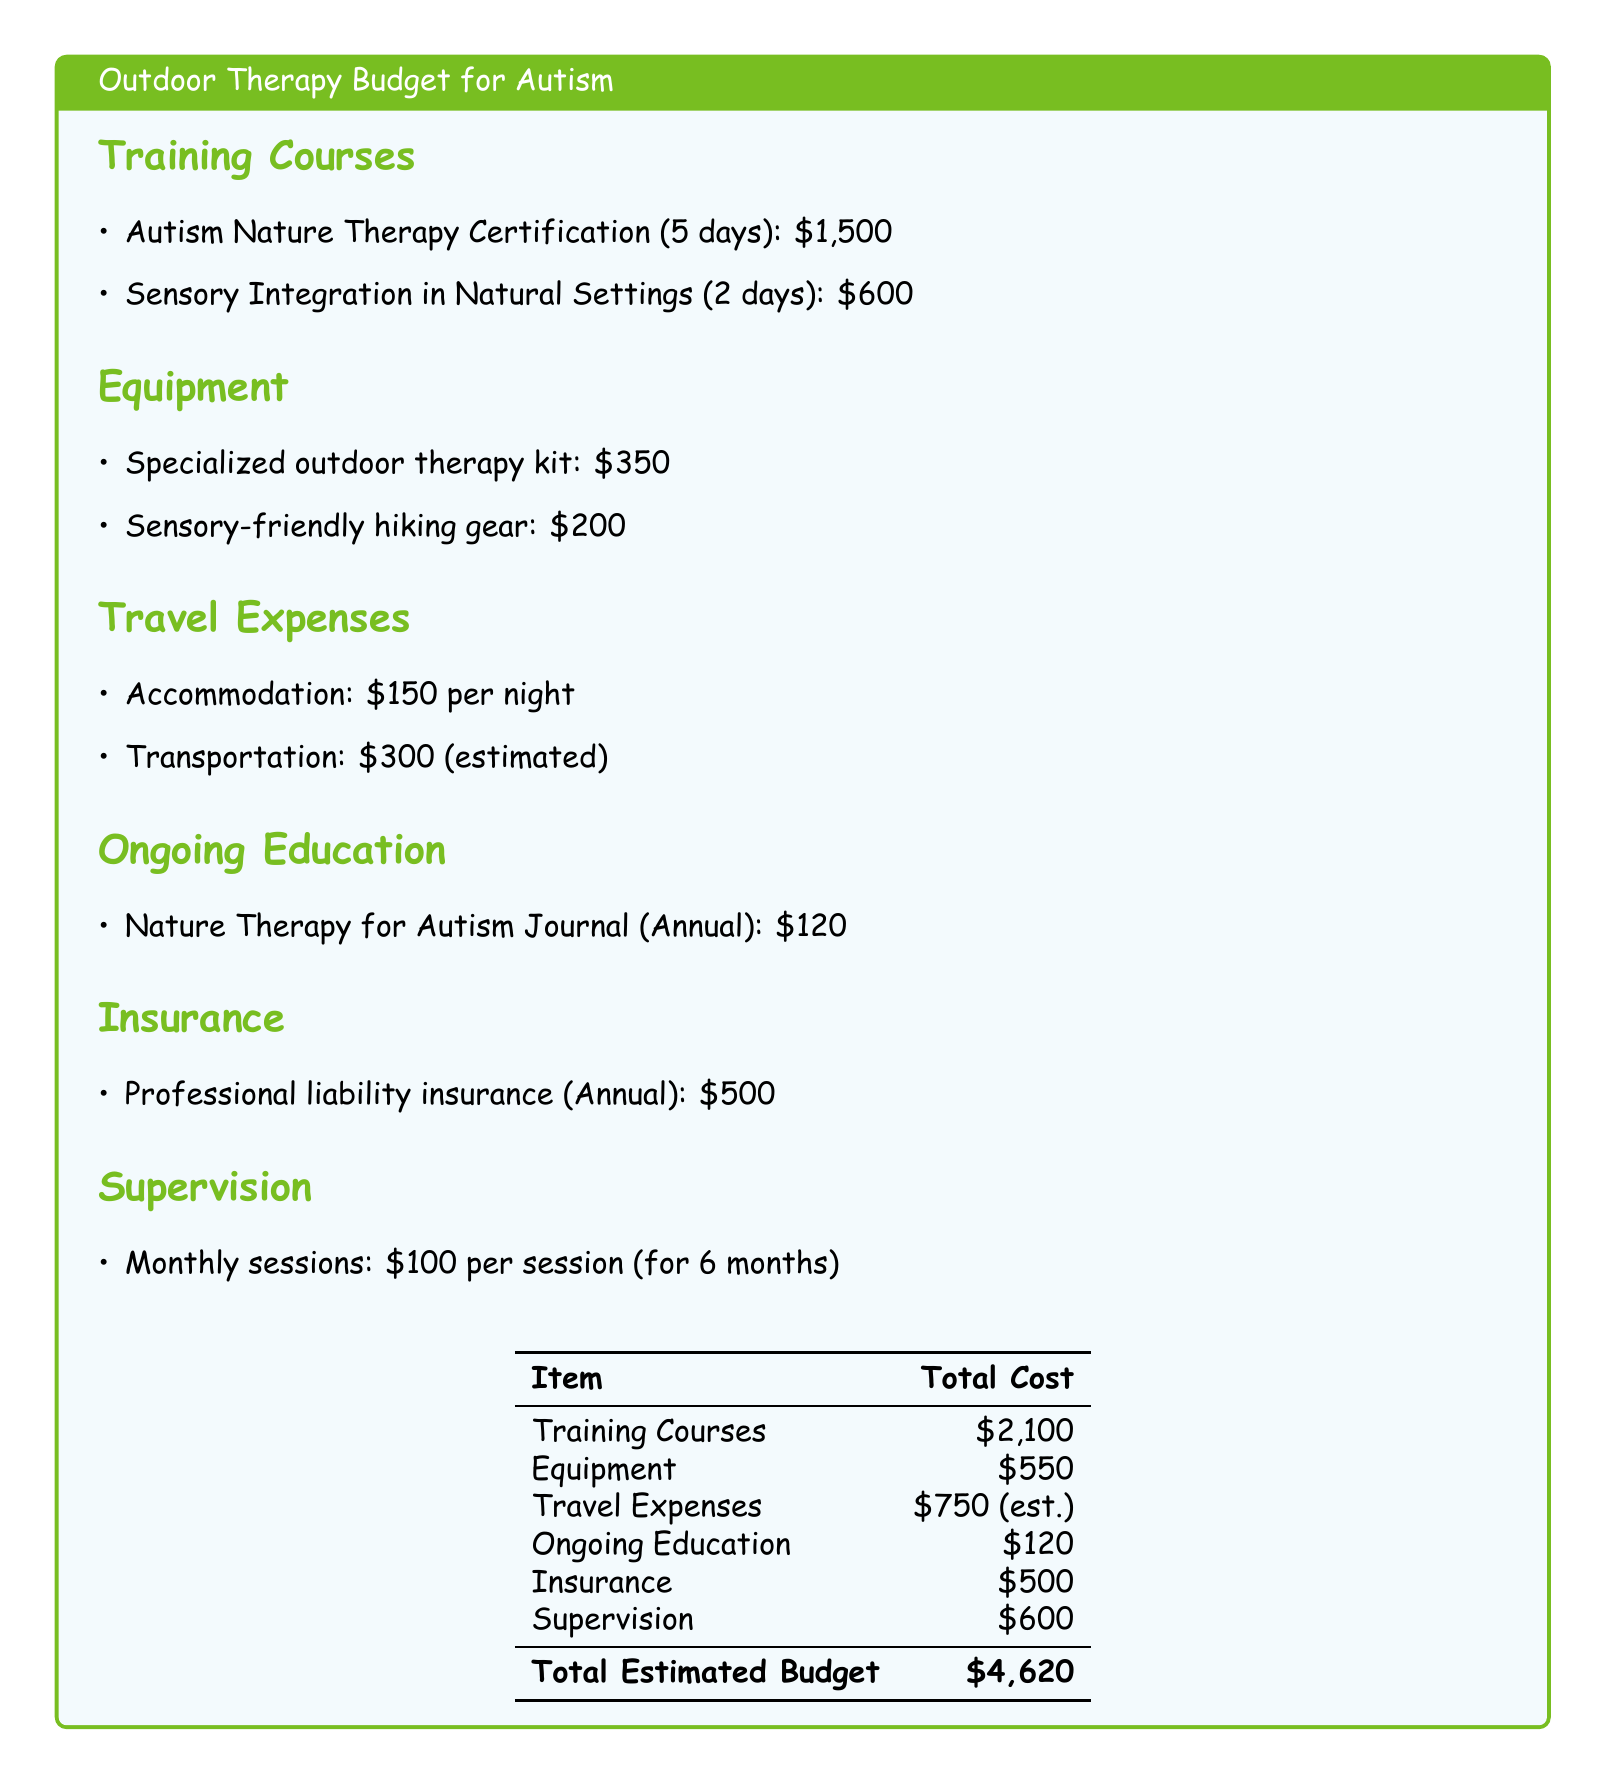What is the cost of the Autism Nature Therapy Certification? The cost is specifically listed in the training courses section of the document.
Answer: $1,500 How many days is the Sensory Integration in Natural Settings course? This course length is stated directly in the training courses section.
Answer: 2 days What is the estimated total for travel expenses? The travel expenses are summarized in a single line within the travel expenses section.
Answer: $750 (est.) How much does the nature therapy journal cost annually? The cost of the journal is provided in the ongoing education section.
Answer: $120 What is the total cost for equipment? The total for equipment is calculated by adding the individual costs in the equipment section.
Answer: $550 What will be the total estimated budget for the outdoor therapy training? The total estimated budget can be found in the summary table at the bottom of the document.
Answer: $4,620 How often are the supervision sessions? The frequency of the sessions is implied by the monthly specification in the supervision section.
Answer: Monthly What type of insurance is listed, and what is its annual cost? The type of insurance and its cost are clearly mentioned in the insurance section.
Answer: Professional liability insurance (Annual): $500 What is included in the specialized outdoor therapy kit? This is likely a detail that's implied to consist of various outdoor therapy tools but is not itemized.
Answer: Not specified 